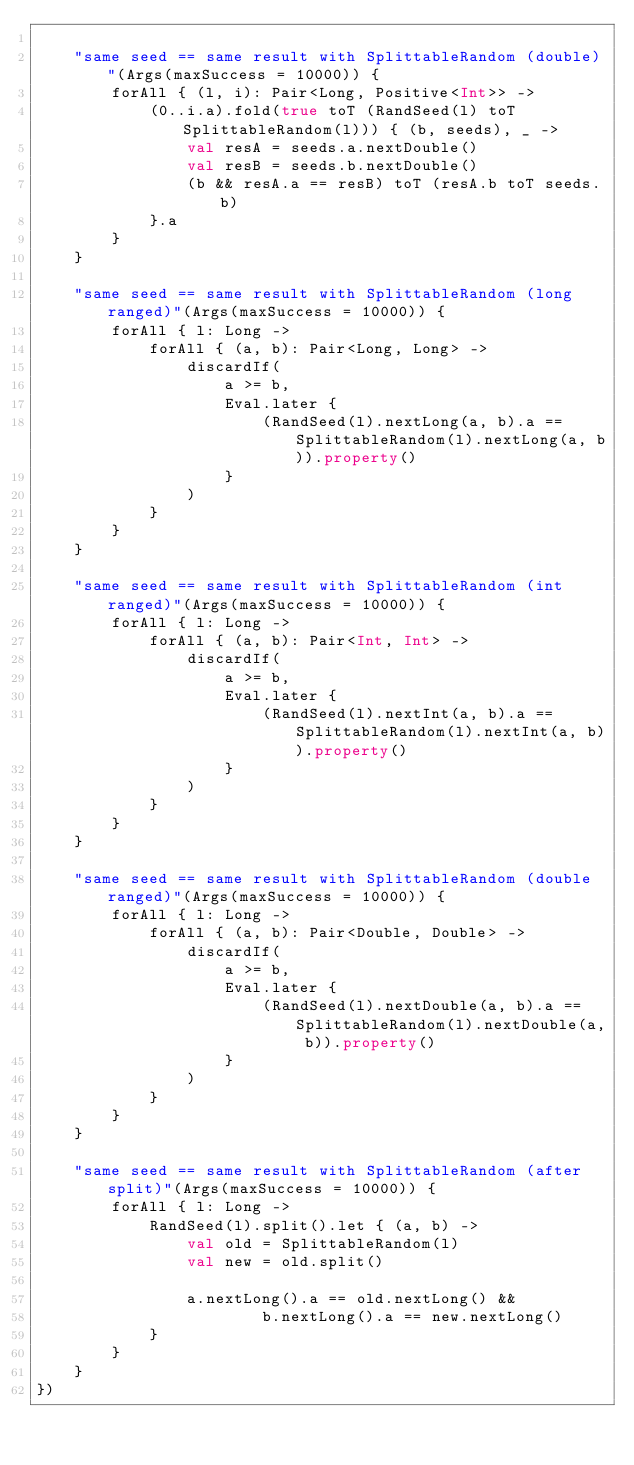Convert code to text. <code><loc_0><loc_0><loc_500><loc_500><_Kotlin_>
    "same seed == same result with SplittableRandom (double)"(Args(maxSuccess = 10000)) {
        forAll { (l, i): Pair<Long, Positive<Int>> ->
            (0..i.a).fold(true toT (RandSeed(l) toT SplittableRandom(l))) { (b, seeds), _ ->
                val resA = seeds.a.nextDouble()
                val resB = seeds.b.nextDouble()
                (b && resA.a == resB) toT (resA.b toT seeds.b)
            }.a
        }
    }

    "same seed == same result with SplittableRandom (long ranged)"(Args(maxSuccess = 10000)) {
        forAll { l: Long ->
            forAll { (a, b): Pair<Long, Long> ->
                discardIf(
                    a >= b,
                    Eval.later {
                        (RandSeed(l).nextLong(a, b).a == SplittableRandom(l).nextLong(a, b)).property()
                    }
                )
            }
        }
    }

    "same seed == same result with SplittableRandom (int ranged)"(Args(maxSuccess = 10000)) {
        forAll { l: Long ->
            forAll { (a, b): Pair<Int, Int> ->
                discardIf(
                    a >= b,
                    Eval.later {
                        (RandSeed(l).nextInt(a, b).a == SplittableRandom(l).nextInt(a, b)).property()
                    }
                )
            }
        }
    }

    "same seed == same result with SplittableRandom (double ranged)"(Args(maxSuccess = 10000)) {
        forAll { l: Long ->
            forAll { (a, b): Pair<Double, Double> ->
                discardIf(
                    a >= b,
                    Eval.later {
                        (RandSeed(l).nextDouble(a, b).a == SplittableRandom(l).nextDouble(a, b)).property()
                    }
                )
            }
        }
    }

    "same seed == same result with SplittableRandom (after split)"(Args(maxSuccess = 10000)) {
        forAll { l: Long ->
            RandSeed(l).split().let { (a, b) ->
                val old = SplittableRandom(l)
                val new = old.split()

                a.nextLong().a == old.nextLong() &&
                        b.nextLong().a == new.nextLong()
            }
        }
    }
})</code> 